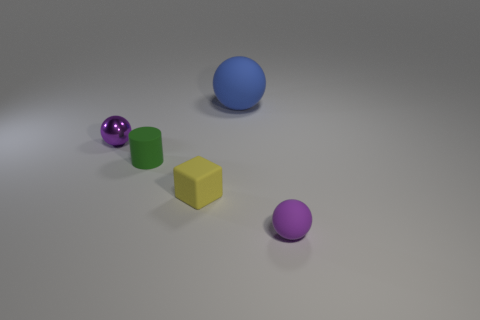Add 4 tiny green rubber things. How many objects exist? 9 Subtract all spheres. How many objects are left? 2 Add 1 purple matte things. How many purple matte things exist? 2 Subtract 1 yellow blocks. How many objects are left? 4 Subtract all brown metallic spheres. Subtract all purple matte objects. How many objects are left? 4 Add 3 small purple shiny things. How many small purple shiny things are left? 4 